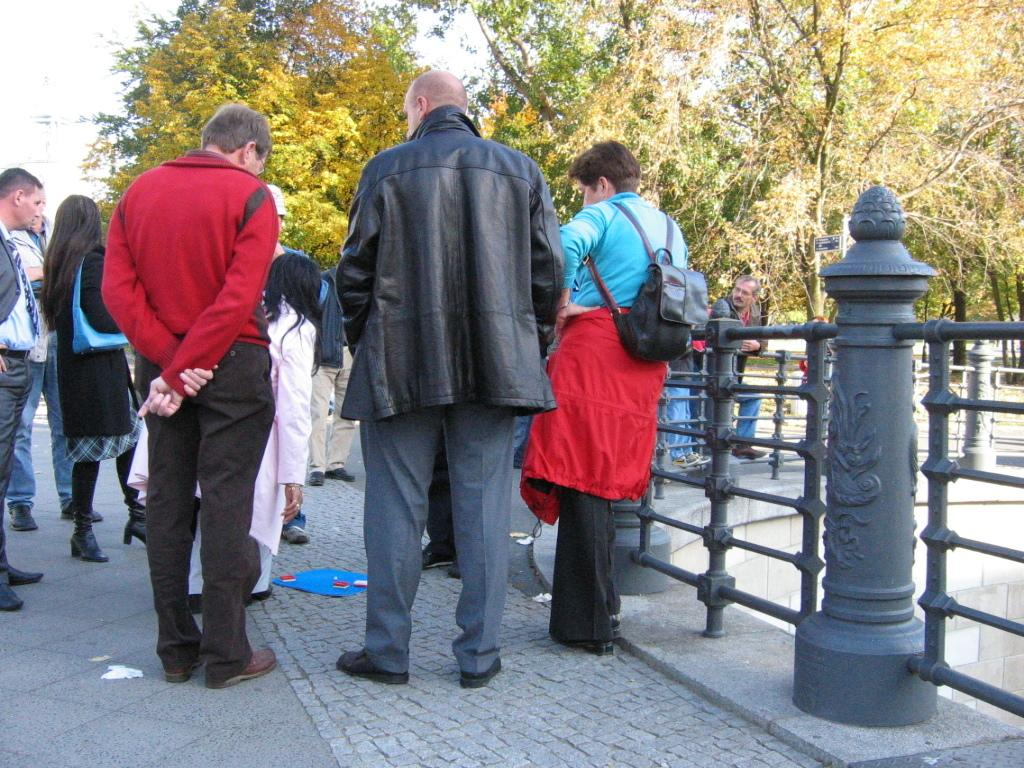What are the people in the image doing? The people in the image are standing in the center. What can be seen on the right side of the image? There is a railing on the right side of the image. What is visible in the background of the image? There are trees and the sky visible in the background of the image. How many cacti can be seen in the image? There are no cacti present in the image. 